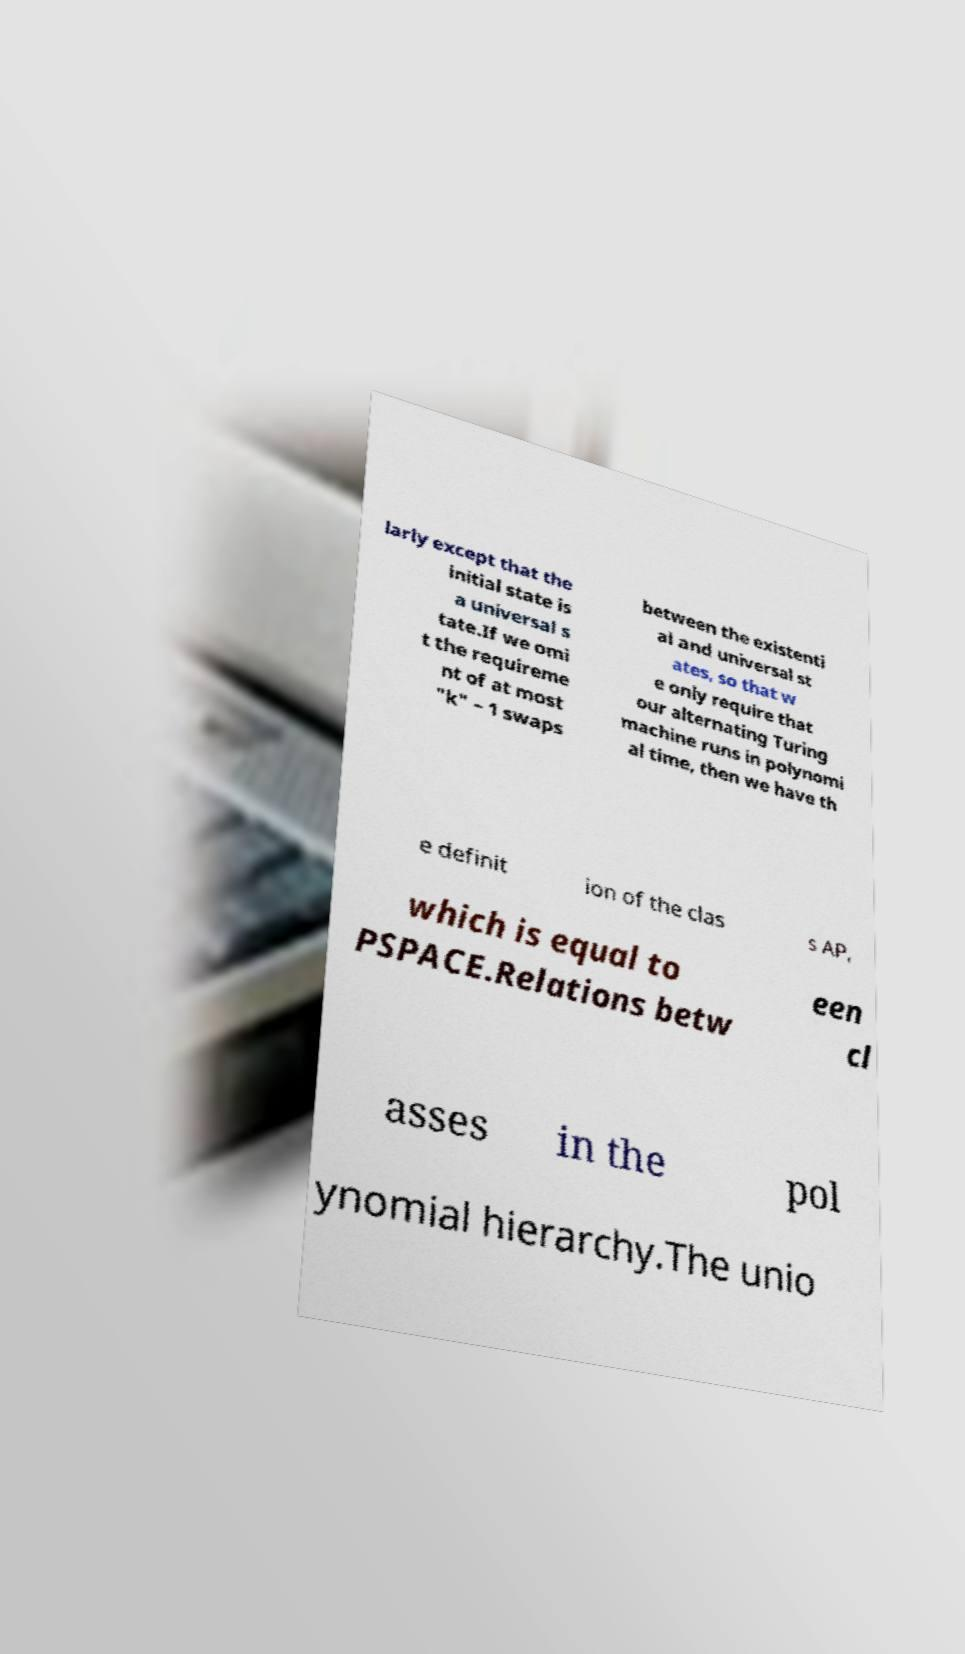What messages or text are displayed in this image? I need them in a readable, typed format. larly except that the initial state is a universal s tate.If we omi t the requireme nt of at most "k" – 1 swaps between the existenti al and universal st ates, so that w e only require that our alternating Turing machine runs in polynomi al time, then we have th e definit ion of the clas s AP, which is equal to PSPACE.Relations betw een cl asses in the pol ynomial hierarchy.The unio 